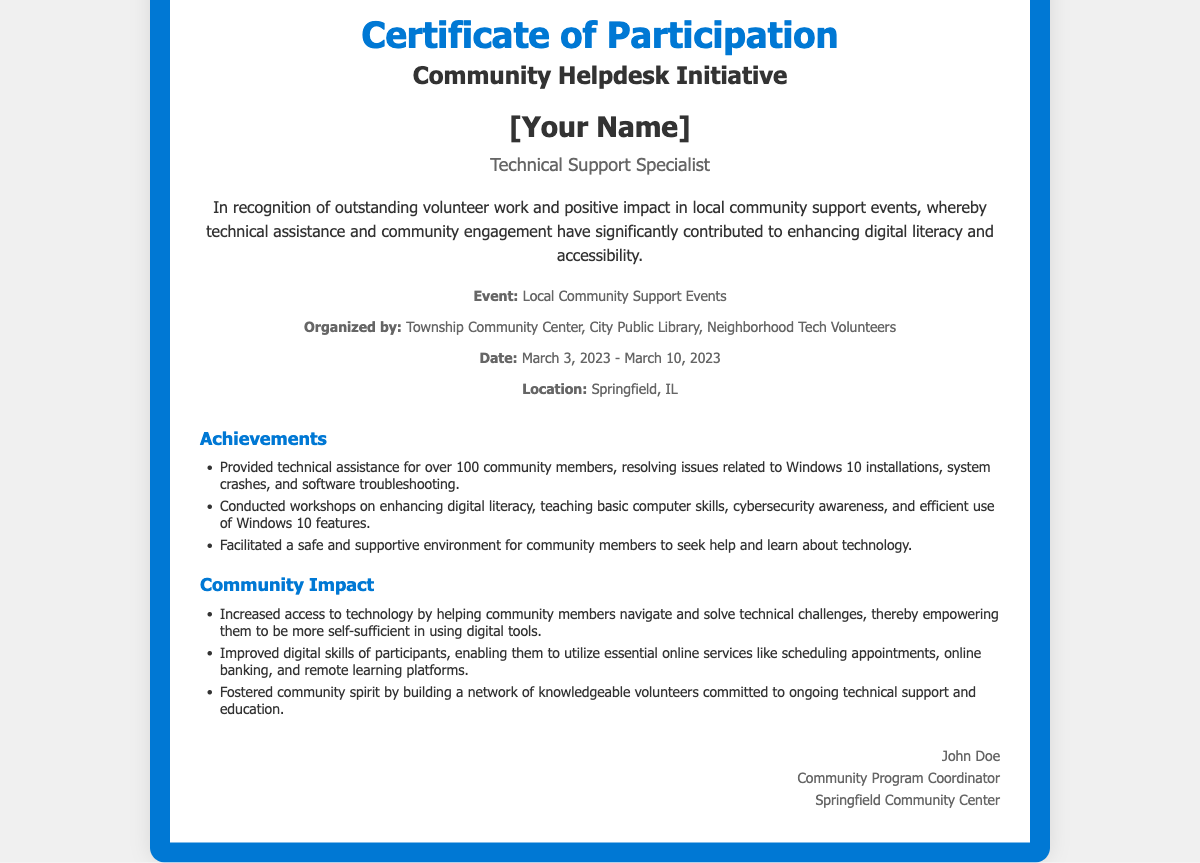what is the title of the certificate? The title of the certificate is prominently displayed at the top of the document.
Answer: Certificate of Participation who received the certificate? The recipient's name is indicated in the document and is a placeholder in the content.
Answer: [Your Name] what was the role of the recipient? The role is specified in the content section under the name.
Answer: Technical Support Specialist which organization organized the event? The organizing body is mentioned in the event details section.
Answer: Township Community Center, City Public Library, Neighborhood Tech Volunteers what were the dates of the event? The event dates are clearly stated in the event details section.
Answer: March 3, 2023 - March 10, 2023 how many community members received technical assistance? This number is found in the achievements section of the document.
Answer: over 100 what skill topics were covered in the workshops? The workshop topics are included in the achievements section of the document.
Answer: basic computer skills, cybersecurity awareness, efficient use of Windows 10 features what is one impact of the community initiative? The community impact is discussed in a dedicated section of the document.
Answer: Increased access to technology who signed the certificate? The signature section lists the name of the individual signing the certificate.
Answer: John Doe 